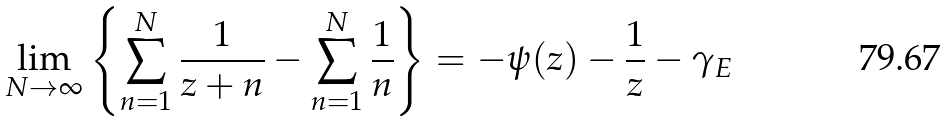Convert formula to latex. <formula><loc_0><loc_0><loc_500><loc_500>\lim _ { N \rightarrow \infty } \left \{ \sum _ { n = 1 } ^ { N } \frac { 1 } { z + n } - \sum _ { n = 1 } ^ { N } \frac { 1 } { n } \right \} = - \psi ( z ) - \frac { 1 } { z } - \gamma _ { E }</formula> 